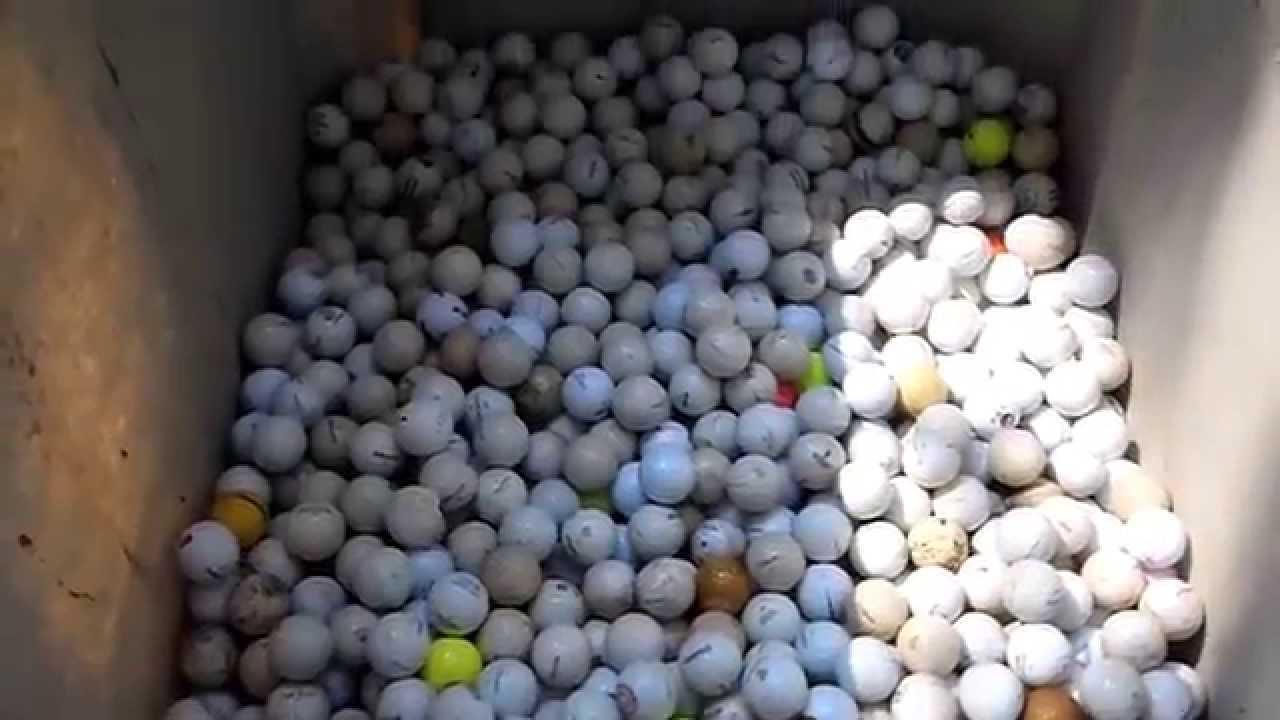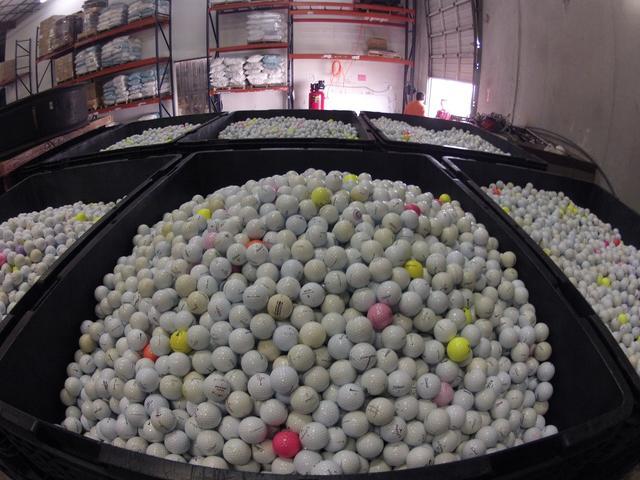The first image is the image on the left, the second image is the image on the right. For the images shown, is this caption "An image shows many golf balls piled into a squarish tub container." true? Answer yes or no. Yes. The first image is the image on the left, the second image is the image on the right. Evaluate the accuracy of this statement regarding the images: "Some of the balls are sitting in tubs.". Is it true? Answer yes or no. Yes. 